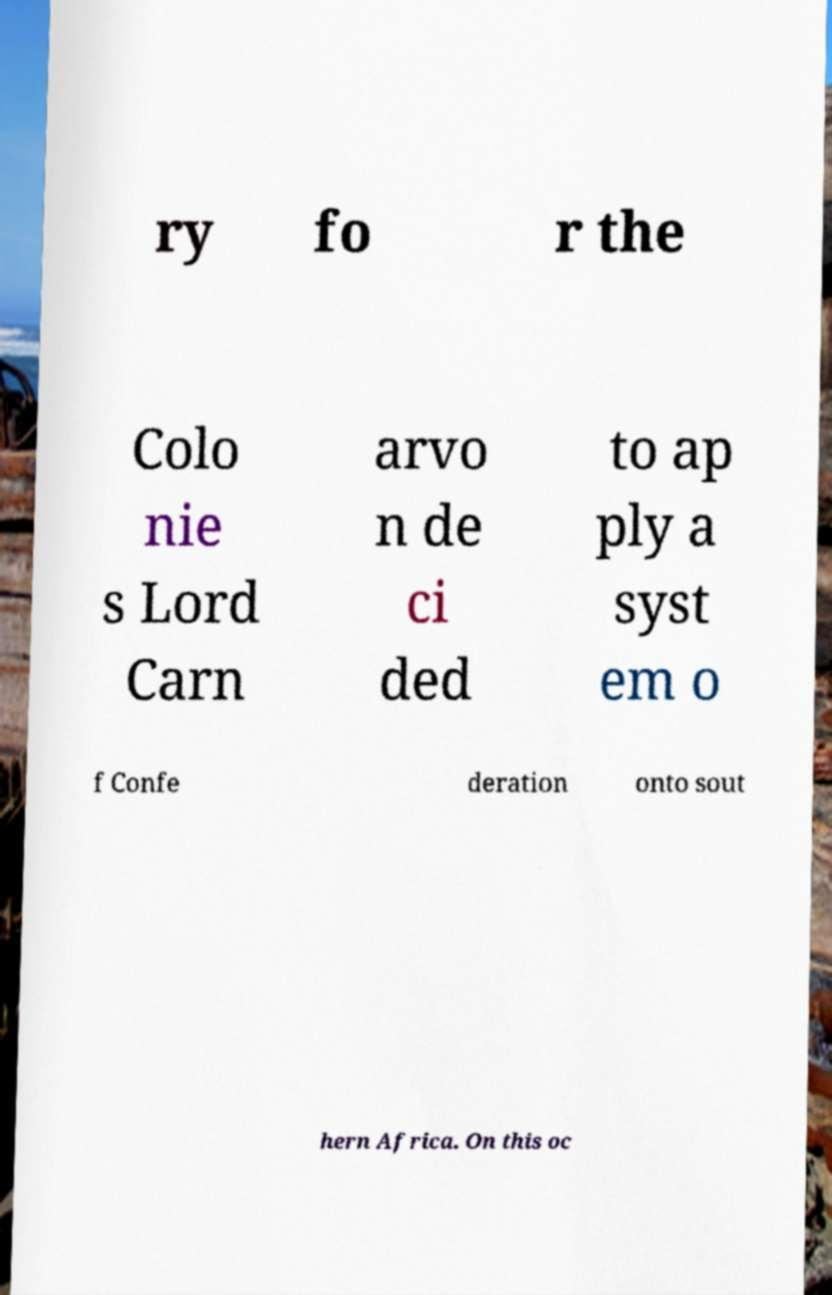Could you assist in decoding the text presented in this image and type it out clearly? ry fo r the Colo nie s Lord Carn arvo n de ci ded to ap ply a syst em o f Confe deration onto sout hern Africa. On this oc 